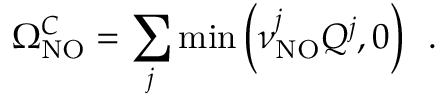<formula> <loc_0><loc_0><loc_500><loc_500>\Omega _ { N O } ^ { C } = \sum _ { j } \min \left ( \nu _ { N O } ^ { j } Q ^ { j } , 0 \right ) \, .</formula> 